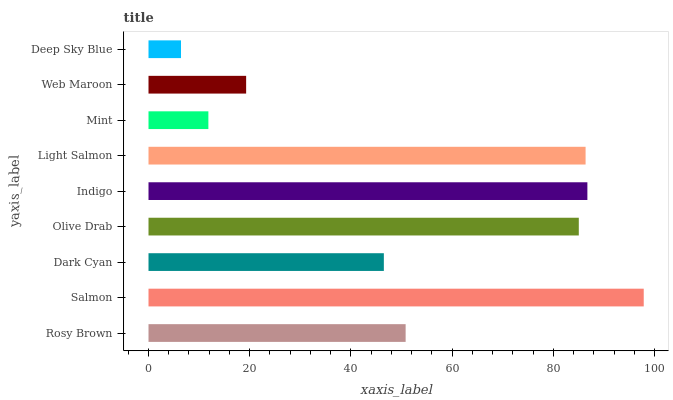Is Deep Sky Blue the minimum?
Answer yes or no. Yes. Is Salmon the maximum?
Answer yes or no. Yes. Is Dark Cyan the minimum?
Answer yes or no. No. Is Dark Cyan the maximum?
Answer yes or no. No. Is Salmon greater than Dark Cyan?
Answer yes or no. Yes. Is Dark Cyan less than Salmon?
Answer yes or no. Yes. Is Dark Cyan greater than Salmon?
Answer yes or no. No. Is Salmon less than Dark Cyan?
Answer yes or no. No. Is Rosy Brown the high median?
Answer yes or no. Yes. Is Rosy Brown the low median?
Answer yes or no. Yes. Is Mint the high median?
Answer yes or no. No. Is Dark Cyan the low median?
Answer yes or no. No. 